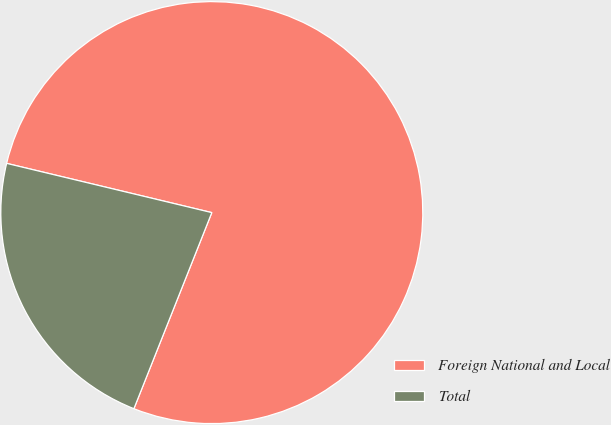<chart> <loc_0><loc_0><loc_500><loc_500><pie_chart><fcel>Foreign National and Local<fcel>Total<nl><fcel>77.27%<fcel>22.73%<nl></chart> 